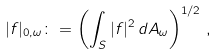<formula> <loc_0><loc_0><loc_500><loc_500>| f | _ { 0 , \omega } \colon = \left ( \int _ { S } | f | ^ { 2 } \, d A _ { \omega } \right ) ^ { 1 / 2 } \, ,</formula> 